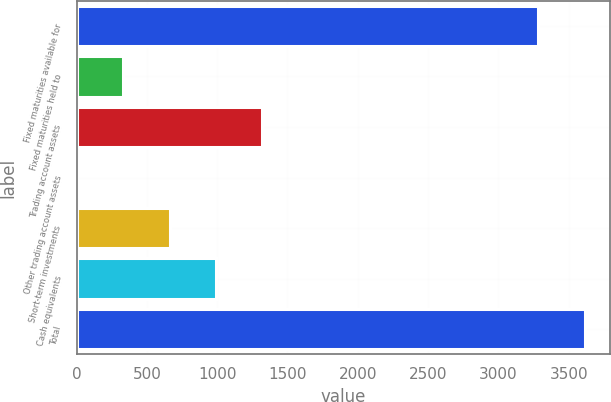Convert chart to OTSL. <chart><loc_0><loc_0><loc_500><loc_500><bar_chart><fcel>Fixed maturities available for<fcel>Fixed maturities held to<fcel>Trading account assets<fcel>Other trading account assets<fcel>Short-term investments<fcel>Cash equivalents<fcel>Total<nl><fcel>3284<fcel>331.1<fcel>1321.4<fcel>1<fcel>661.2<fcel>991.3<fcel>3614.1<nl></chart> 